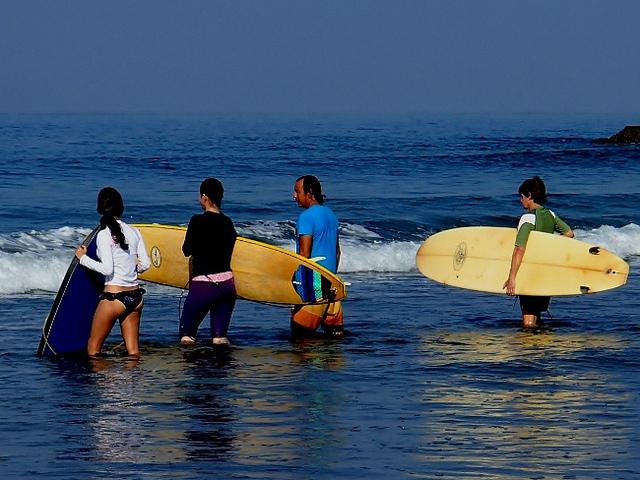How many boards are there?
Short answer required. 3. What is the people about to do?
Keep it brief. Surf. Are they floating?
Keep it brief. No. How many boards are shown?
Answer briefly. 3. What number is on the shirt?
Short answer required. 0. Is the woman's hair wet?
Quick response, please. Yes. Are these people still in high school?
Write a very short answer. No. Is the sea calm?
Keep it brief. Yes. 